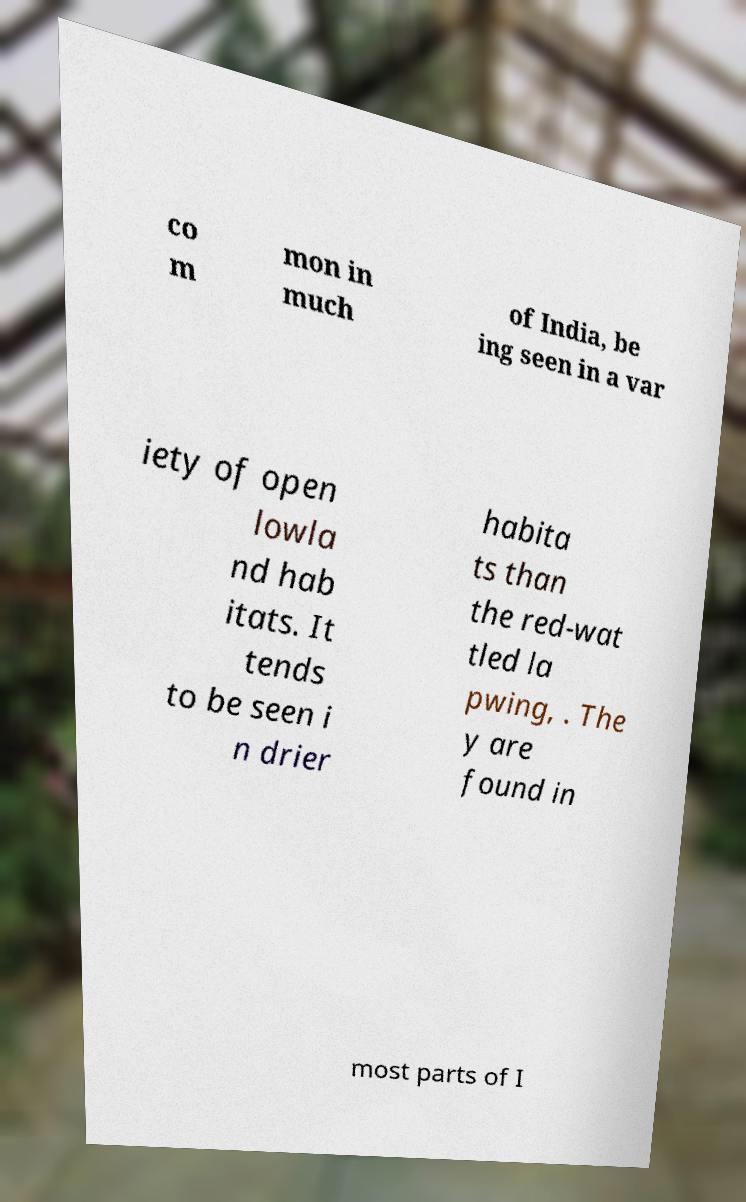Please read and relay the text visible in this image. What does it say? co m mon in much of India, be ing seen in a var iety of open lowla nd hab itats. It tends to be seen i n drier habita ts than the red-wat tled la pwing, . The y are found in most parts of I 